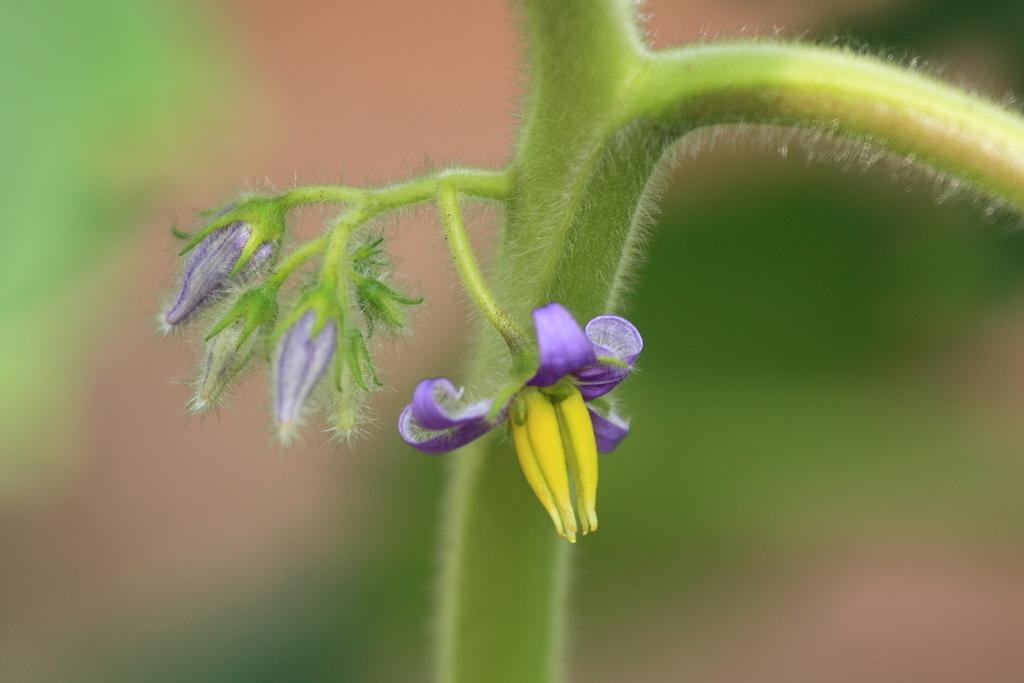Can you describe this image briefly? In this image we can see group of flowers on the stem of a plant. 